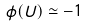<formula> <loc_0><loc_0><loc_500><loc_500>\phi ( U ) \simeq - 1</formula> 